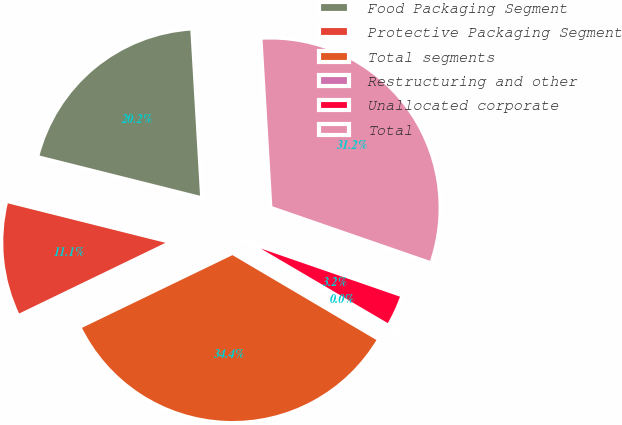Convert chart to OTSL. <chart><loc_0><loc_0><loc_500><loc_500><pie_chart><fcel>Food Packaging Segment<fcel>Protective Packaging Segment<fcel>Total segments<fcel>Restructuring and other<fcel>Unallocated corporate<fcel>Total<nl><fcel>20.16%<fcel>11.07%<fcel>34.35%<fcel>0.03%<fcel>3.15%<fcel>31.23%<nl></chart> 